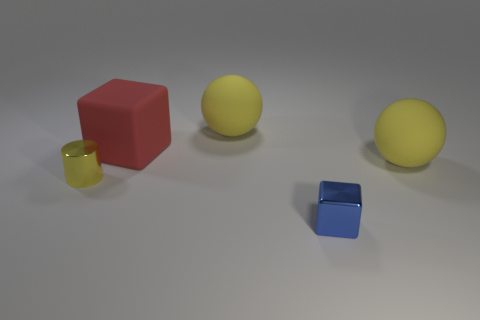Can you describe the shapes and materials of the objects in the image? Certainly! There is a large red cube, a large yellow rubber ducky, a small transparent yellow cup, a small blue metal cube, and a yellow sphere. The materials appear to be rubber for the ducky, metal for the small cube, and possibly plastic for the red cube, the cup, and the yellow sphere. 